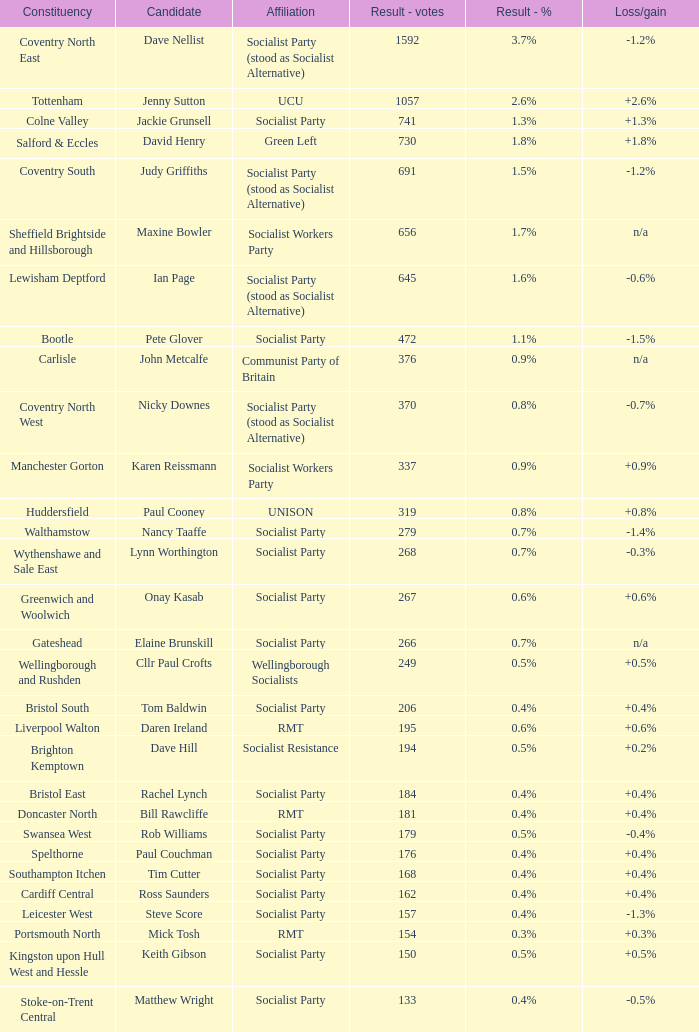What is every affiliation for the Tottenham constituency? UCU. 